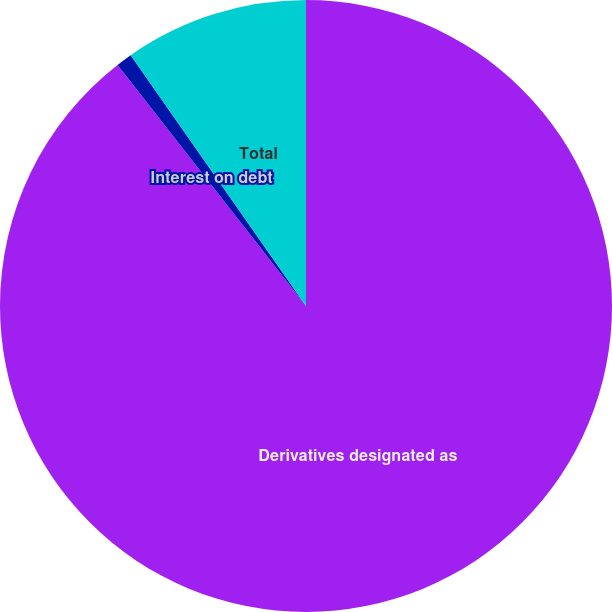Convert chart to OTSL. <chart><loc_0><loc_0><loc_500><loc_500><pie_chart><fcel>Derivatives designated as<fcel>Interest on debt<fcel>Total<nl><fcel>89.45%<fcel>0.85%<fcel>9.71%<nl></chart> 